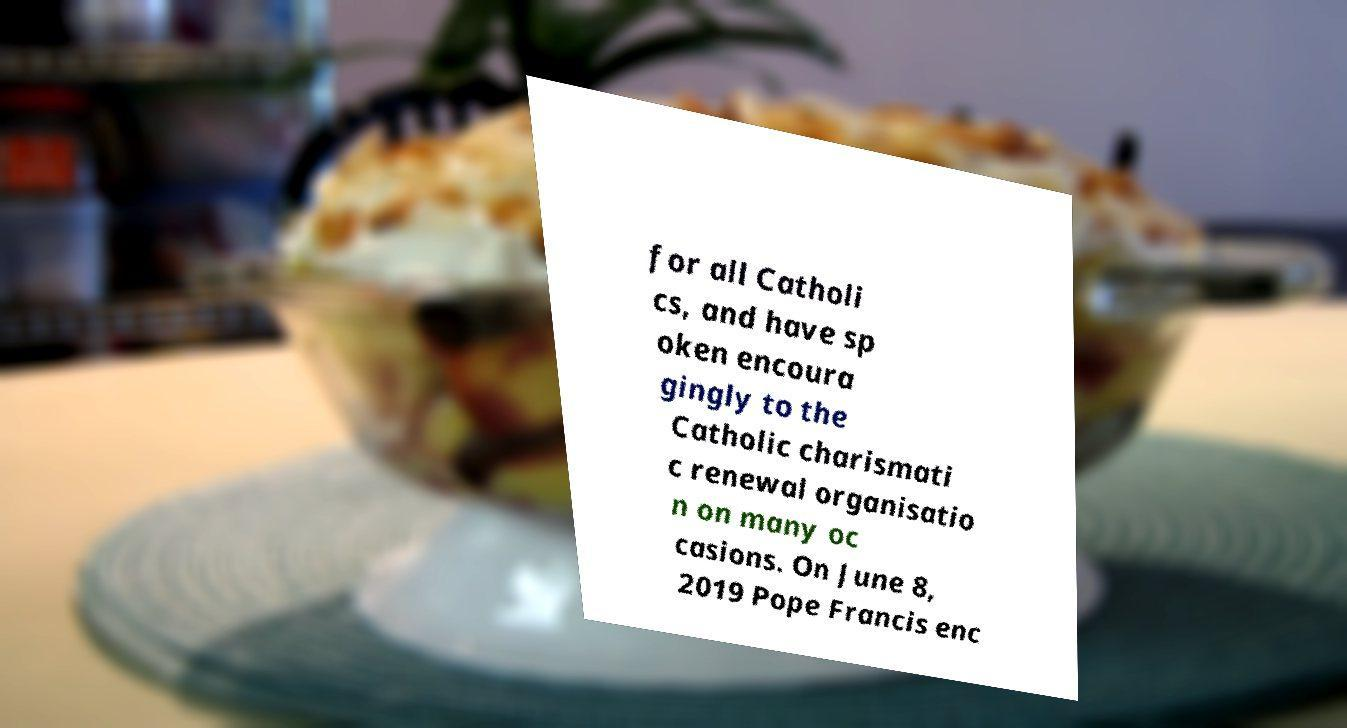Can you accurately transcribe the text from the provided image for me? for all Catholi cs, and have sp oken encoura gingly to the Catholic charismati c renewal organisatio n on many oc casions. On June 8, 2019 Pope Francis enc 